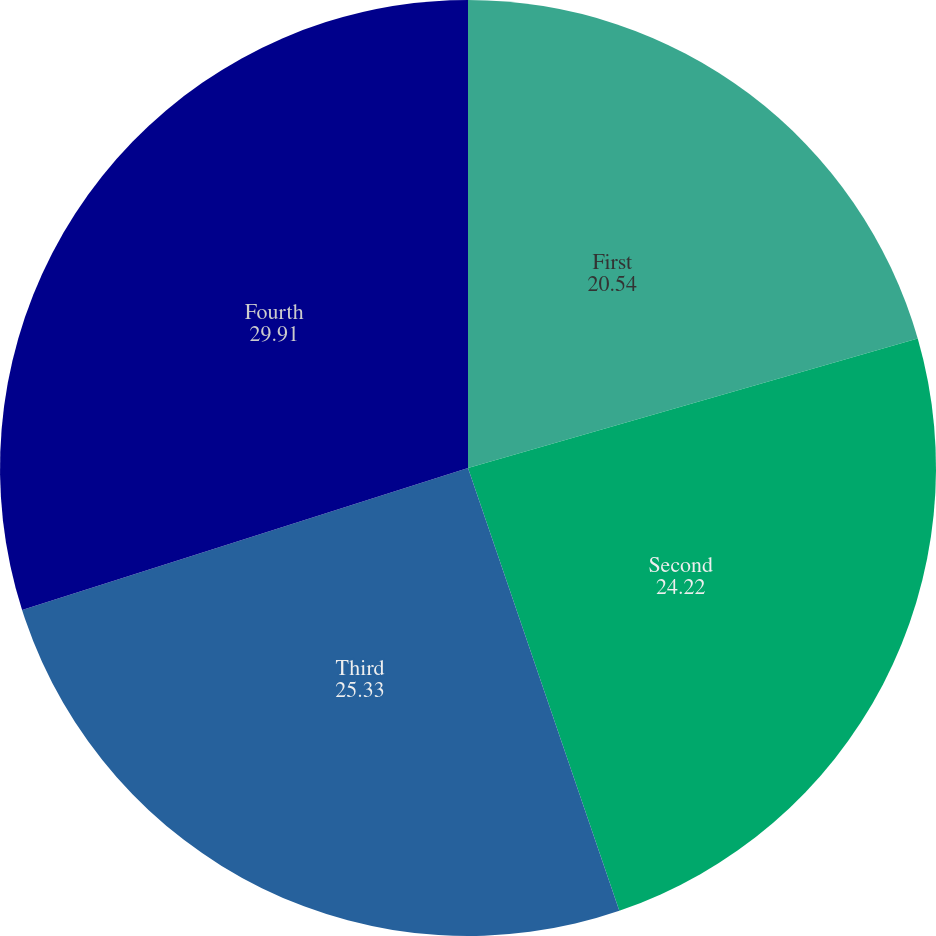<chart> <loc_0><loc_0><loc_500><loc_500><pie_chart><fcel>First<fcel>Second<fcel>Third<fcel>Fourth<nl><fcel>20.54%<fcel>24.22%<fcel>25.33%<fcel>29.91%<nl></chart> 